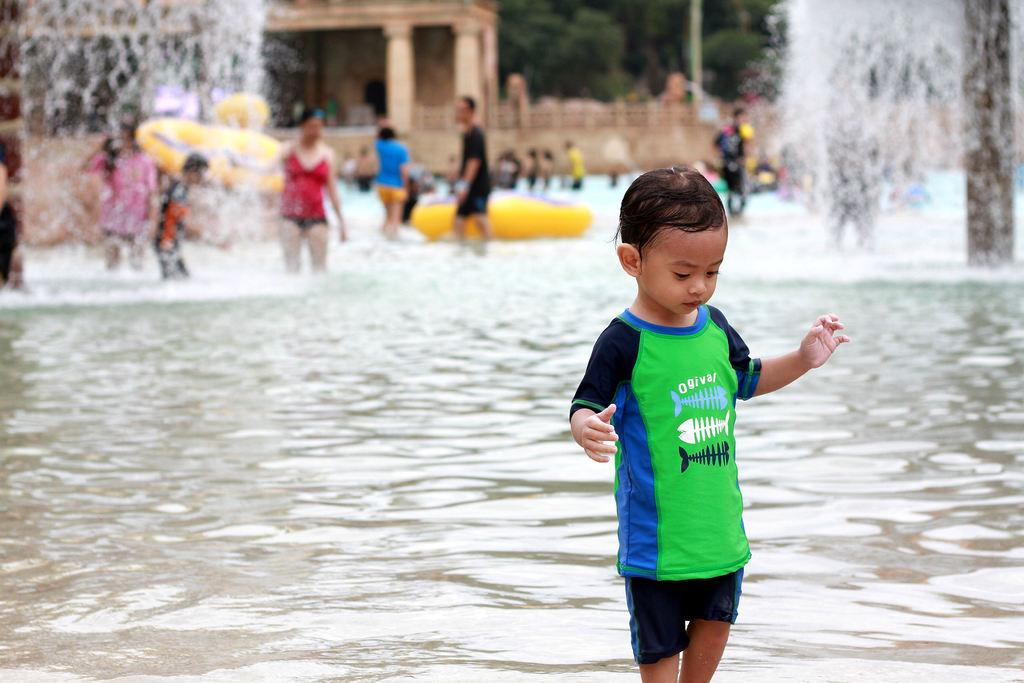What is the main subject of the image? There is a baby child in the image. What is the baby child doing in the image? The baby child is standing in the water. What can be seen in the background of the image? There is a building and a wall in the background of the image. What type of tank is visible in the image? There is no tank present in the image. Can you tell me how many tickets the baby child is holding in the image? There are no tickets visible in the image. 